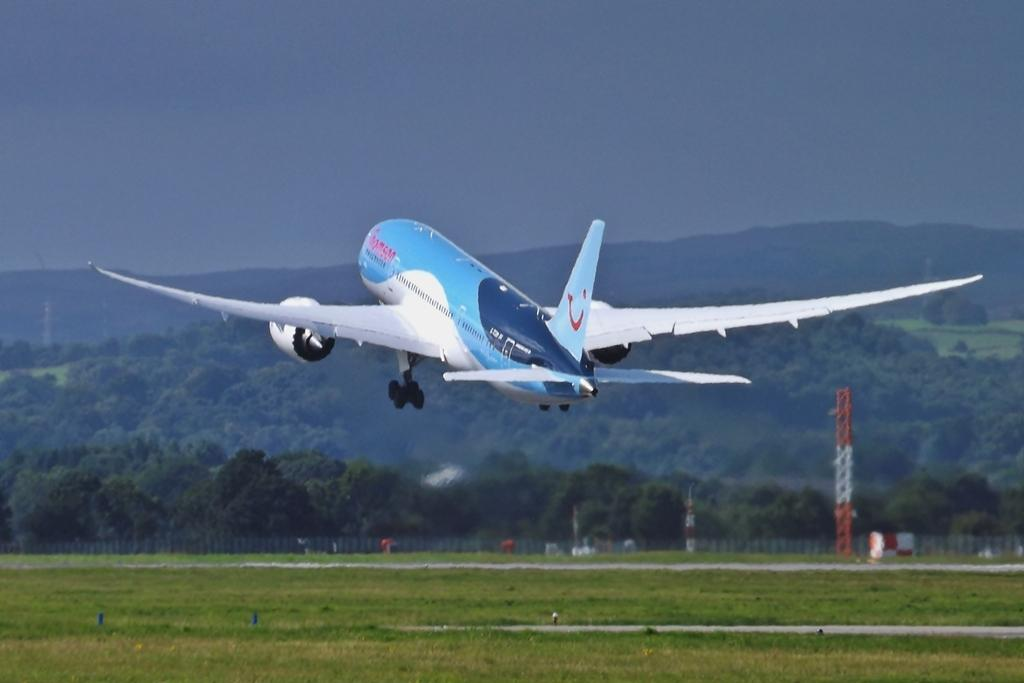What is happening in the image? There is a flight flying in the image. What can be seen on the ground in the image? There is grass on the ground in the image. What structures are visible in the background of the image? There are towers and trees visible in the background of the image. What type of terrain is present in the background of the image? There is a hill in the background of the image. What is visible above the structures and terrain in the image? The sky is visible in the background of the image. What type of crime is being committed in the image? There is no crime being committed in the image; it features a flight flying over a landscape with grass, towers, trees, a hill, and the sky. What type of gun is visible in the image? There is no gun present in the image. 